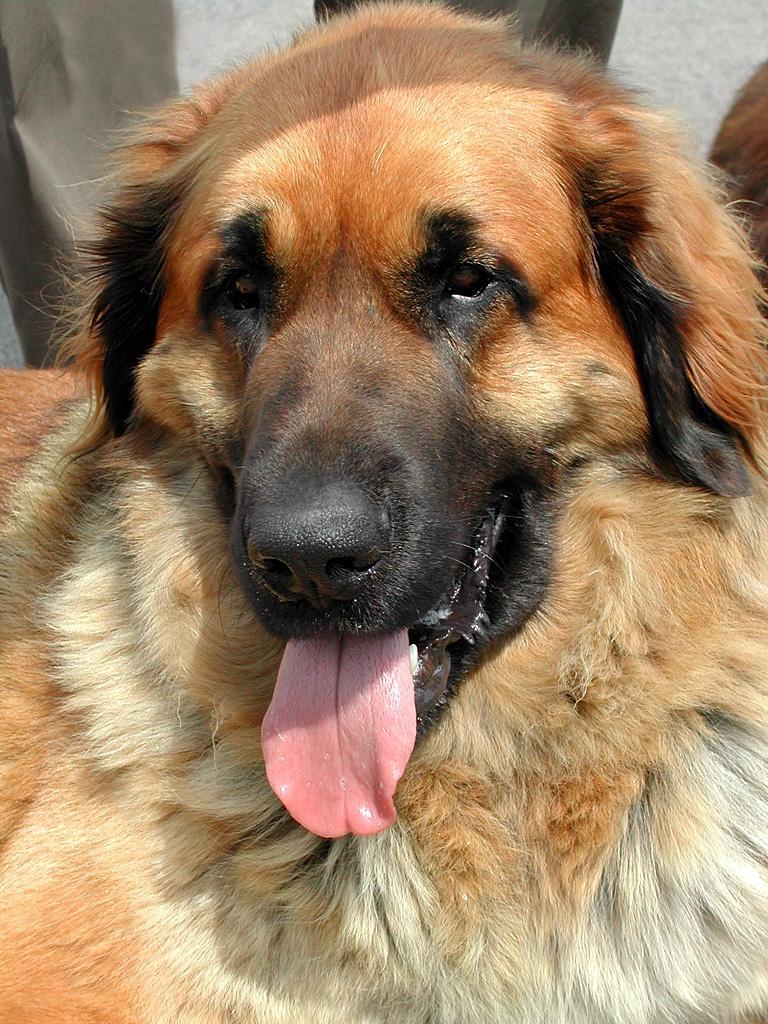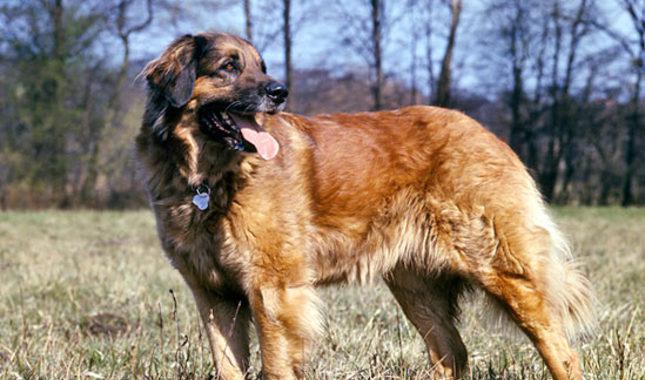The first image is the image on the left, the second image is the image on the right. Given the left and right images, does the statement "In one image you can only see the dogs head." hold true? Answer yes or no. Yes. The first image is the image on the left, the second image is the image on the right. Examine the images to the left and right. Is the description "A dog with its face turned rightward is standing still on the grass in one image." accurate? Answer yes or no. Yes. The first image is the image on the left, the second image is the image on the right. Examine the images to the left and right. Is the description "The dog in the image on the right is standing outside alone." accurate? Answer yes or no. Yes. The first image is the image on the left, the second image is the image on the right. For the images displayed, is the sentence "One photo is a closeup of a dog's head and shoulders." factually correct? Answer yes or no. Yes. 